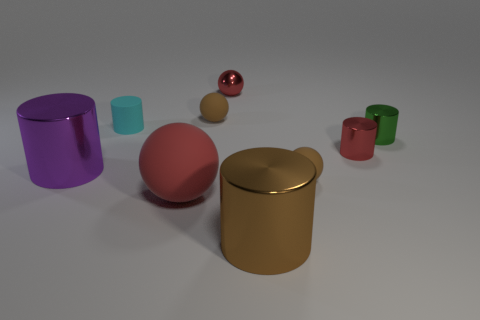What materials appear to be represented in this image? The objects in the image seem to have surfaces that imitate various materials, such as matte, glossy, and metallic textures, suggesting a diversity of materials like plastic, metal, and possibly glass. 